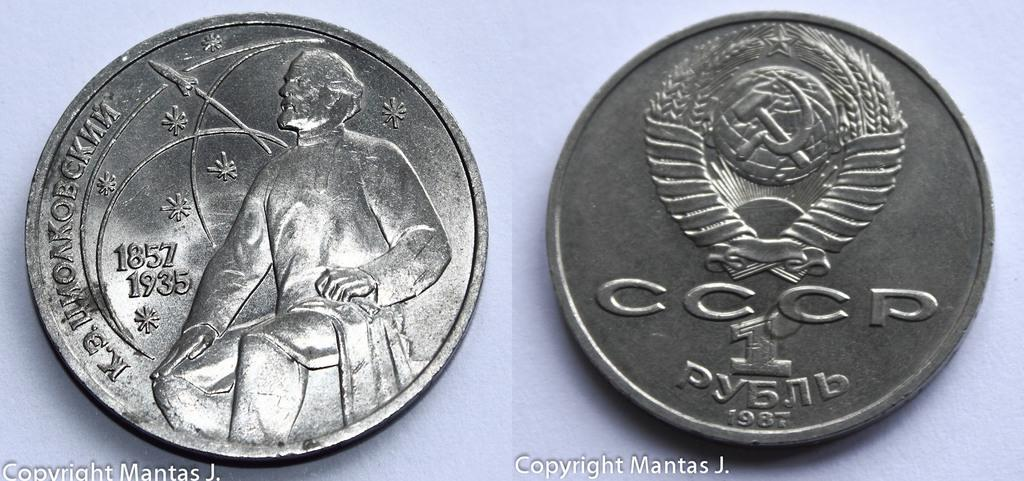<image>
Create a compact narrative representing the image presented. some silver coins, one of which bears the date 1857 